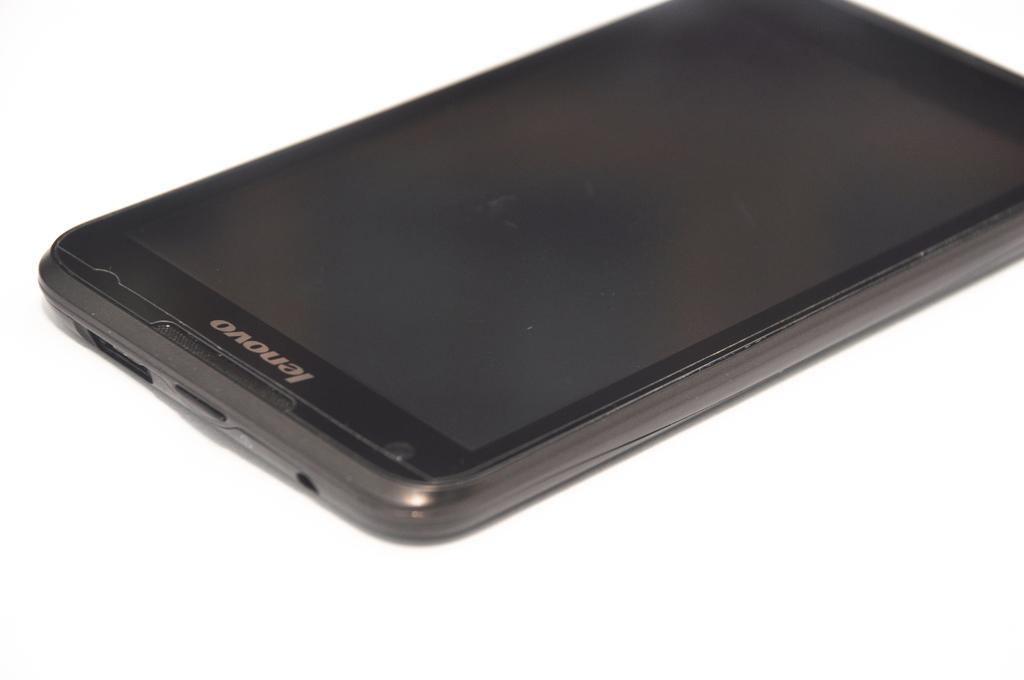<image>
Relay a brief, clear account of the picture shown. A lenovo brand device lying face up and turned off. 